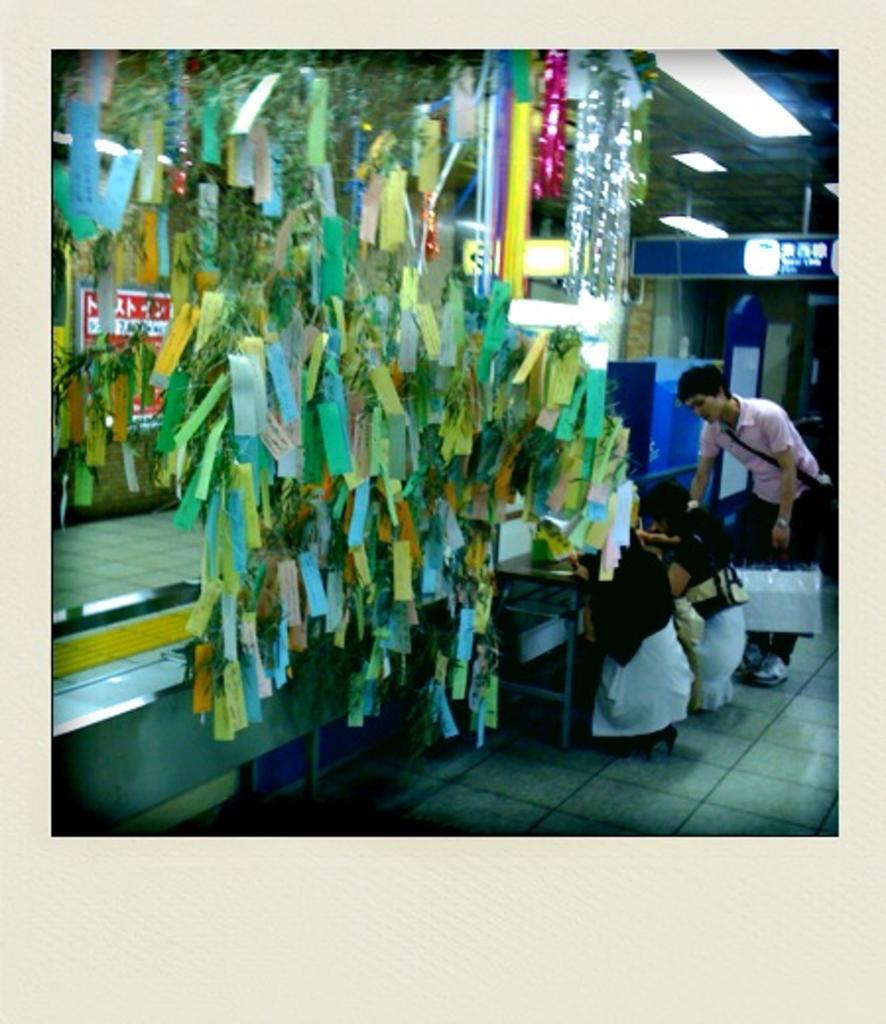How would you summarize this image in a sentence or two? In the center of the image we can see papers and decors. On the right side of the image we can see person at the table. In the background we can see floor and wall. 